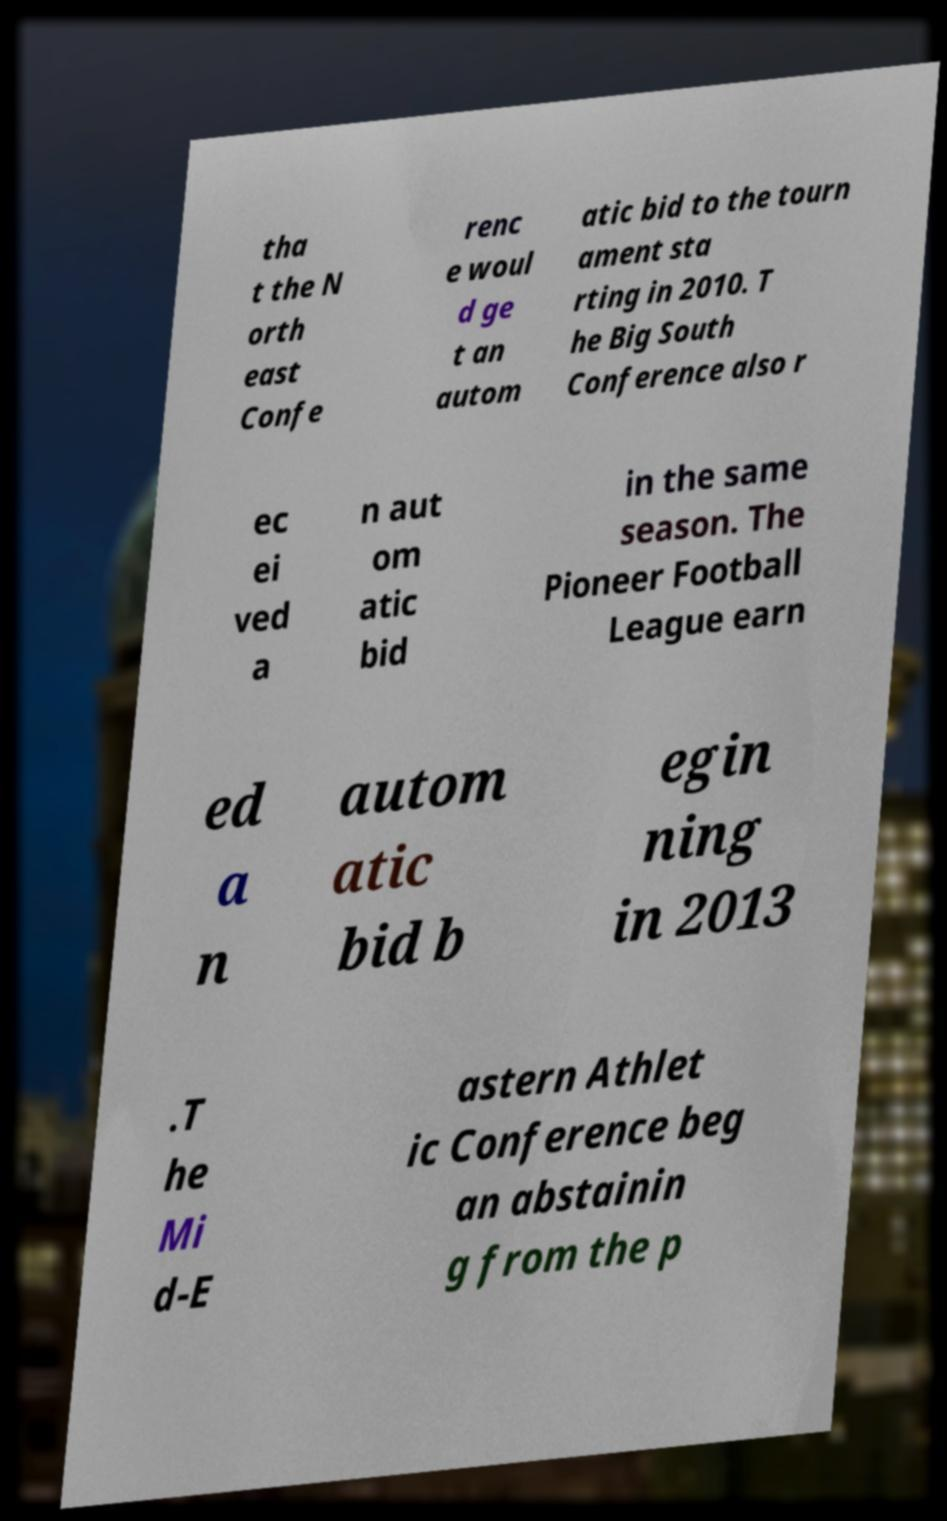Can you read and provide the text displayed in the image?This photo seems to have some interesting text. Can you extract and type it out for me? tha t the N orth east Confe renc e woul d ge t an autom atic bid to the tourn ament sta rting in 2010. T he Big South Conference also r ec ei ved a n aut om atic bid in the same season. The Pioneer Football League earn ed a n autom atic bid b egin ning in 2013 .T he Mi d-E astern Athlet ic Conference beg an abstainin g from the p 